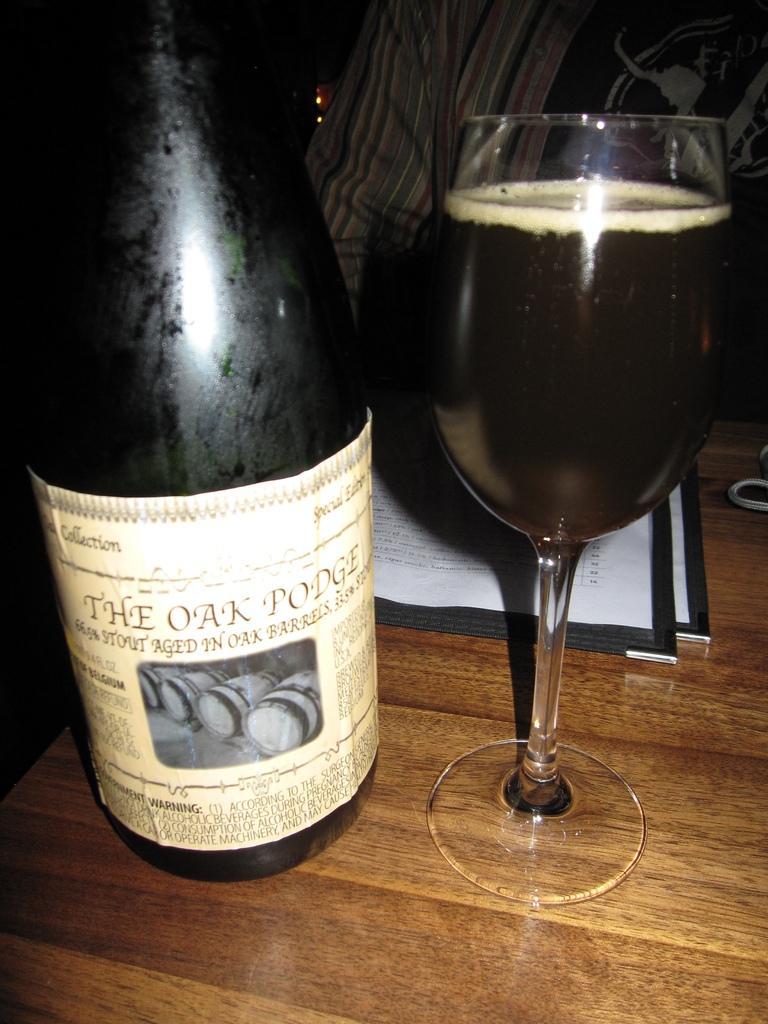Please provide a concise description of this image. In this image, we can see a bottle and a glass with drink and some papers are on the table. In the background, there is a person. 